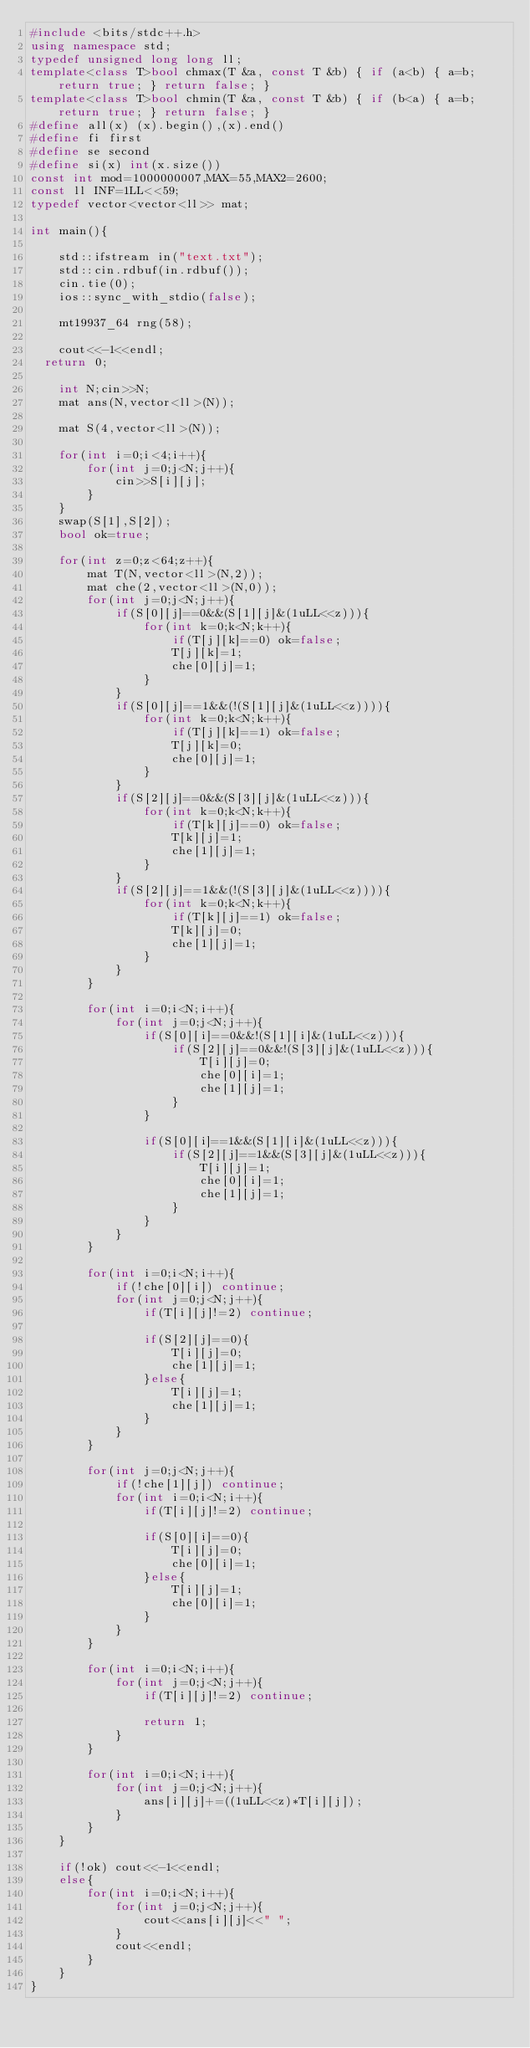<code> <loc_0><loc_0><loc_500><loc_500><_C++_>#include <bits/stdc++.h>
using namespace std;
typedef unsigned long long ll;
template<class T>bool chmax(T &a, const T &b) { if (a<b) { a=b; return true; } return false; }
template<class T>bool chmin(T &a, const T &b) { if (b<a) { a=b; return true; } return false; }
#define all(x) (x).begin(),(x).end()
#define fi first
#define se second
#define si(x) int(x.size())
const int mod=1000000007,MAX=55,MAX2=2600;
const ll INF=1LL<<59;
typedef vector<vector<ll>> mat;

int main(){
    
    std::ifstream in("text.txt");
    std::cin.rdbuf(in.rdbuf());
    cin.tie(0);
    ios::sync_with_stdio(false);
    
    mt19937_64 rng(58);
    
    cout<<-1<<endl;
  return 0;
    
    int N;cin>>N;
    mat ans(N,vector<ll>(N));
    
    mat S(4,vector<ll>(N));
    
    for(int i=0;i<4;i++){
        for(int j=0;j<N;j++){
            cin>>S[i][j];
        }
    }
    swap(S[1],S[2]);
    bool ok=true;
    
    for(int z=0;z<64;z++){
        mat T(N,vector<ll>(N,2));
        mat che(2,vector<ll>(N,0));
        for(int j=0;j<N;j++){
            if(S[0][j]==0&&(S[1][j]&(1uLL<<z))){
                for(int k=0;k<N;k++){
                    if(T[j][k]==0) ok=false;
                    T[j][k]=1;
                    che[0][j]=1;
                }
            }
            if(S[0][j]==1&&(!(S[1][j]&(1uLL<<z)))){
                for(int k=0;k<N;k++){
                    if(T[j][k]==1) ok=false;
                    T[j][k]=0;
                    che[0][j]=1;
                }
            }
            if(S[2][j]==0&&(S[3][j]&(1uLL<<z))){
                for(int k=0;k<N;k++){
                    if(T[k][j]==0) ok=false;
                    T[k][j]=1;
                    che[1][j]=1;
                }
            }
            if(S[2][j]==1&&(!(S[3][j]&(1uLL<<z)))){
                for(int k=0;k<N;k++){
                    if(T[k][j]==1) ok=false;
                    T[k][j]=0;
                    che[1][j]=1;
                }
            }
        }
        
        for(int i=0;i<N;i++){
            for(int j=0;j<N;j++){
                if(S[0][i]==0&&!(S[1][i]&(1uLL<<z))){
                    if(S[2][j]==0&&!(S[3][j]&(1uLL<<z))){
                        T[i][j]=0;
                        che[0][i]=1;
                        che[1][j]=1;
                    }
                }
                
                if(S[0][i]==1&&(S[1][i]&(1uLL<<z))){
                    if(S[2][j]==1&&(S[3][j]&(1uLL<<z))){
                        T[i][j]=1;
                        che[0][i]=1;
                        che[1][j]=1;
                    }
                }
            }
        }
        
        for(int i=0;i<N;i++){
            if(!che[0][i]) continue;
            for(int j=0;j<N;j++){
                if(T[i][j]!=2) continue;
                
                if(S[2][j]==0){
                    T[i][j]=0;
                    che[1][j]=1;
                }else{
                    T[i][j]=1;
                    che[1][j]=1;
                }
            }
        }
        
        for(int j=0;j<N;j++){
            if(!che[1][j]) continue;
            for(int i=0;i<N;i++){
                if(T[i][j]!=2) continue;
                
                if(S[0][i]==0){
                    T[i][j]=0;
                    che[0][i]=1;
                }else{
                    T[i][j]=1;
                    che[0][i]=1;
                }
            }
        }
        
        for(int i=0;i<N;i++){
            for(int j=0;j<N;j++){
                if(T[i][j]!=2) continue;
                
                return 1;
            }
        }
        
        for(int i=0;i<N;i++){
            for(int j=0;j<N;j++){
                ans[i][j]+=((1uLL<<z)*T[i][j]);
            }
        }
    }
    
    if(!ok) cout<<-1<<endl;
    else{
        for(int i=0;i<N;i++){
            for(int j=0;j<N;j++){
                cout<<ans[i][j]<<" ";
            }
            cout<<endl;
        }
    }
}


</code> 